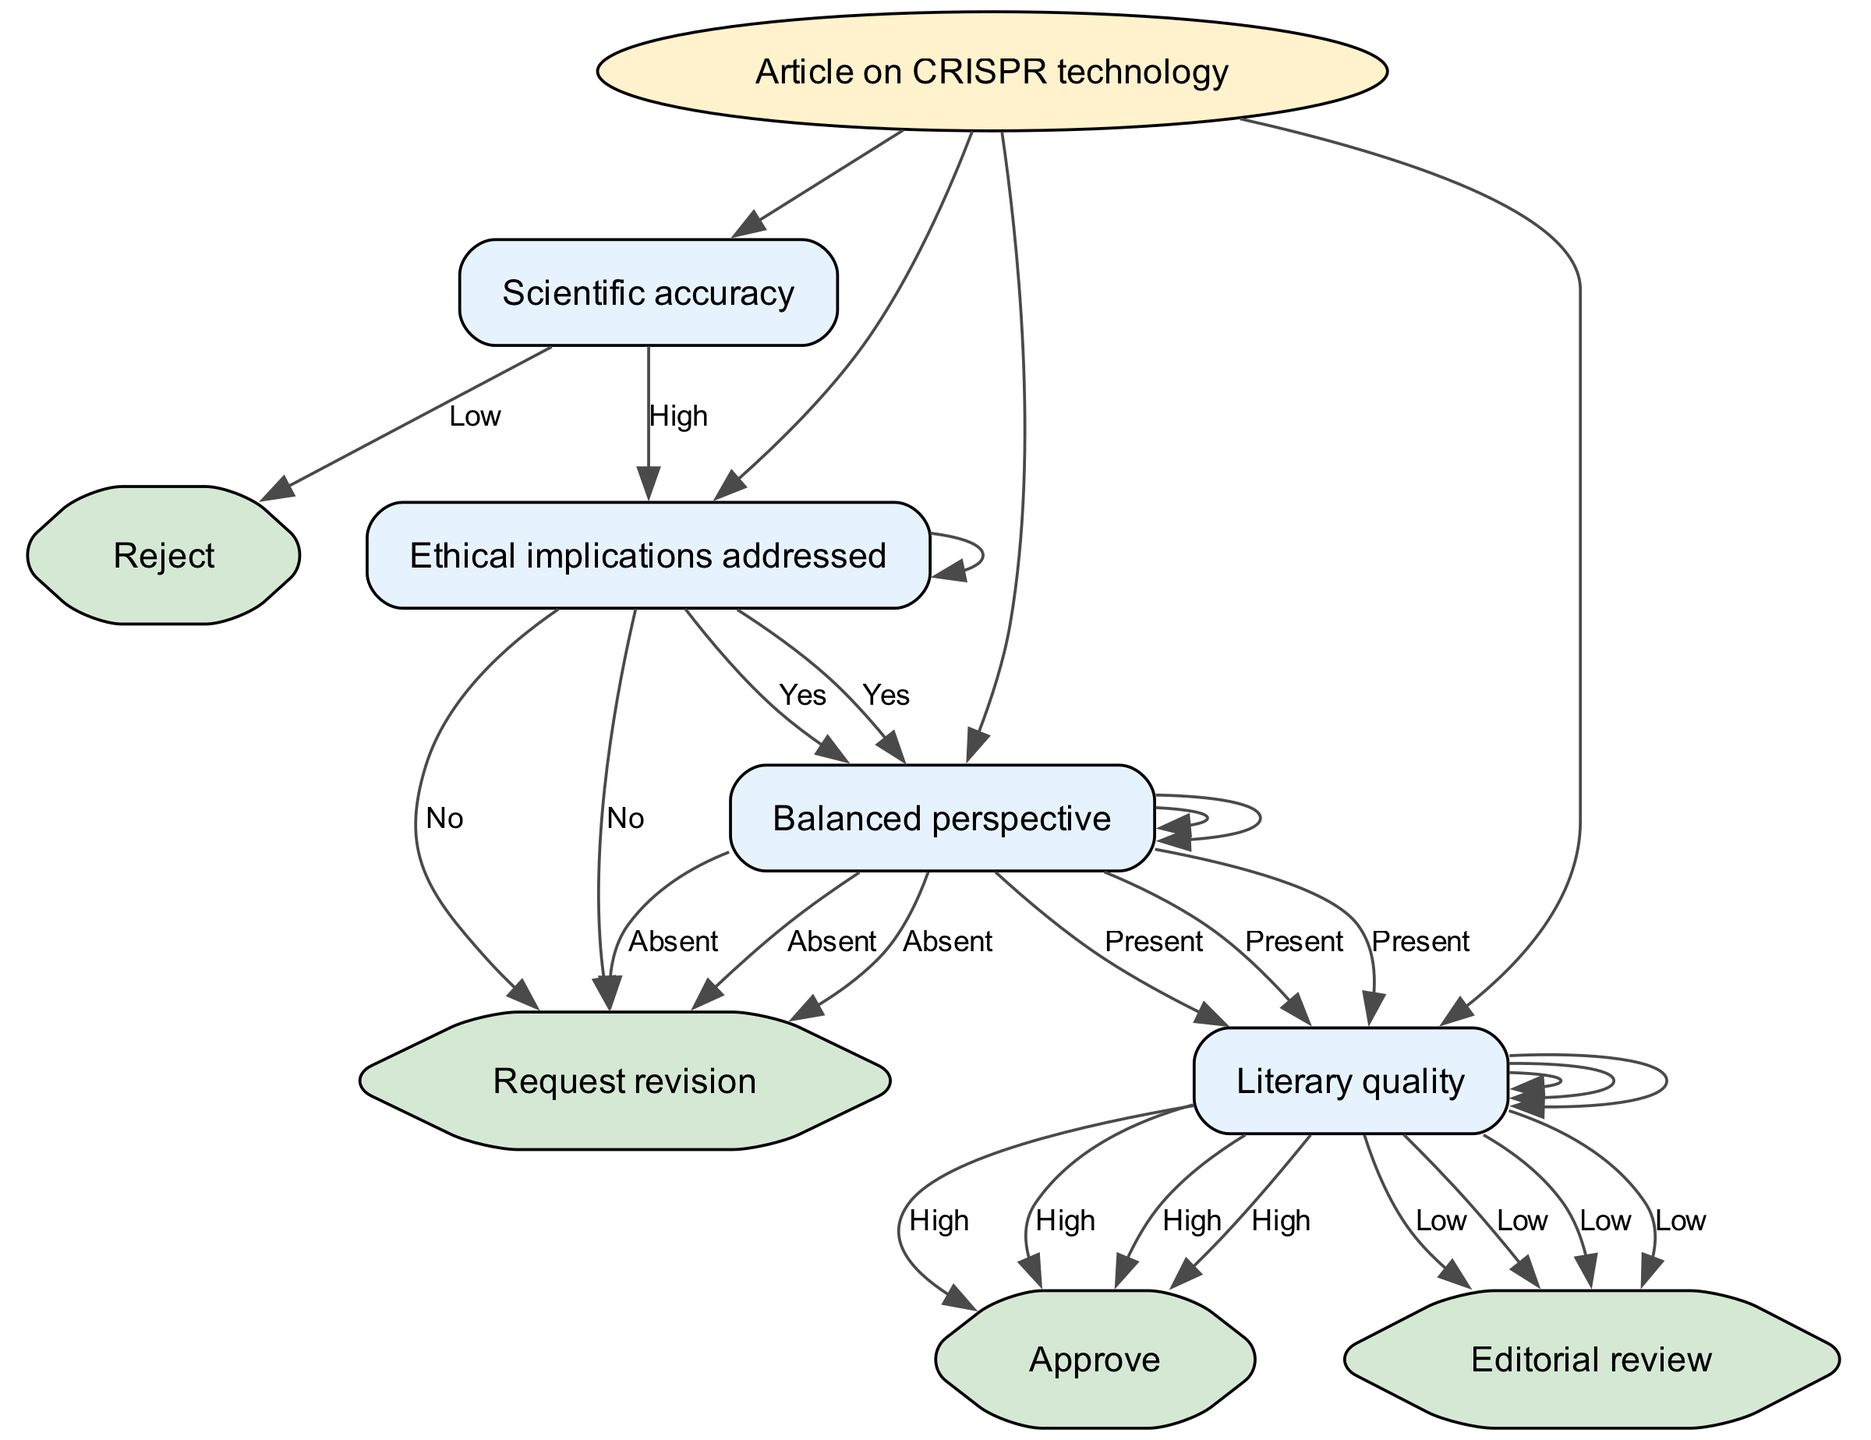What is the root node of the decision tree? The root node is the first point of decision in the tree, which is labeled "Article on CRISPR technology." This indicates the primary subject being considered.
Answer: Article on CRISPR technology How many options are available under the "Scientific accuracy" node? There are two options available under "Scientific accuracy": "High" and "Low." This reflects a binary evaluation of the article's scientific integrity.
Answer: 2 If "Scientific accuracy" is rated as "Low," what is the next step? If "Scientific accuracy" is "Low," the next step is to "Reject" the article. This outcome indicates that insufficient scientific accuracy cannot be tolerated, leading directly to rejection.
Answer: Reject What happens if the "Ethical implications addressed" node has a "No" response? If the response to "Ethical implications addressed" is "No," the next action is to "Request revision." This suggests that the ethical considerations must be improved or clarified before moving forward.
Answer: Request revision What is the final decision if both "Literary quality" is rated as "High" and "Ethical implications addressed" is "Yes"? If both conditions are met, the final decision is to "Approve" the article. This indicates that the article is not only scientifically accurate but also ethically sound and of high literary quality.
Answer: Approve What node follows "Balanced perspective" if the option is "Absent"? If the option is "Absent" under "Balanced perspective," the next step is to "Request revision." This shows that a balanced view is essential for approval, and lacking that requires further editing.
Answer: Request revision How many end nodes are present in the decision tree? The decision tree has four end nodes: "Reject," "Approve," "Request revision," and "Editorial review." These represent the possible outcomes of the article evaluation process.
Answer: 4 What is the next node after determining a "High" rating for "Scientific accuracy"? After determining a "High" rating for "Scientific accuracy," the next node to consider is "Ethical implications addressed." This shows a sequential evaluation based on established criteria.
Answer: Ethical implications addressed 